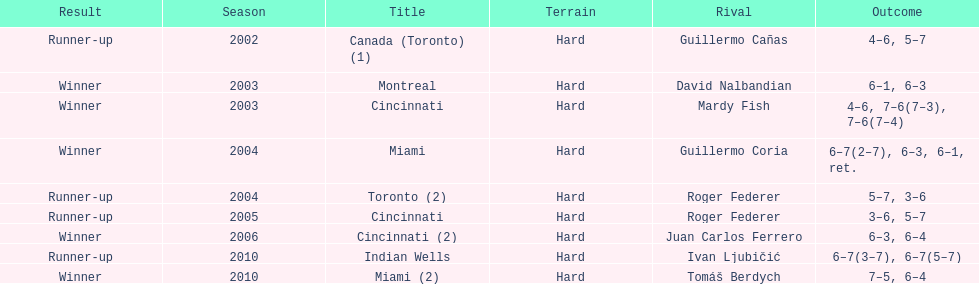What is his highest number of consecutive wins? 3. 